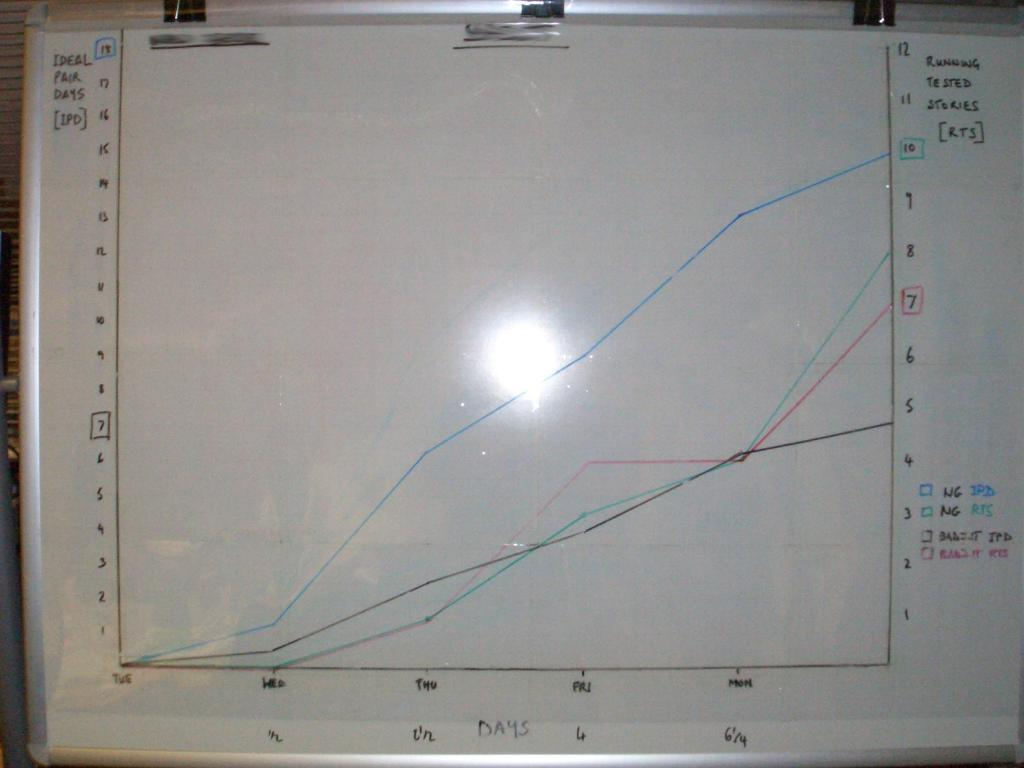Provide a one-sentence caption for the provided image. A line graph with Ideal Pair days (IPD) in the y axis and days in the x axis. 